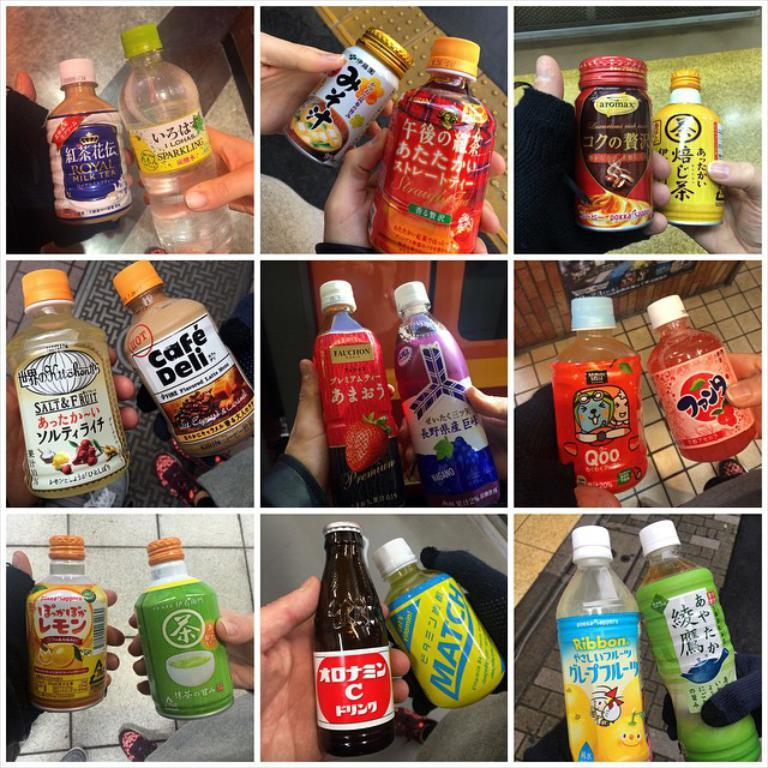<image>
Write a terse but informative summary of the picture. Nine separate panels each feature two beverages with labels in both English and foreign characters describing the bottle's contents. 